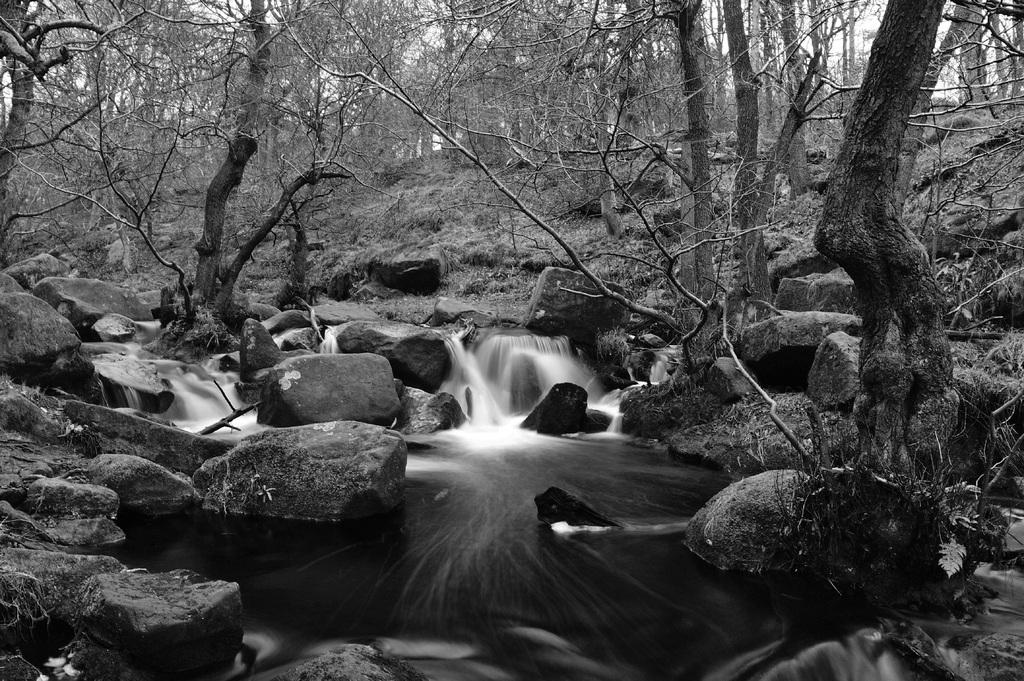What type of vegetation can be seen in the image? There are trees in the image. What is visible at the bottom of the image? There is water visible at the bottom of the image. What other natural elements can be seen in the image? There are rocks in the image. Is there any quicksand visible in the image? No, there is no quicksand present in the image. What type of engine can be seen powering the trees in the image? There is no engine present in the image, and trees do not require engines to function. 